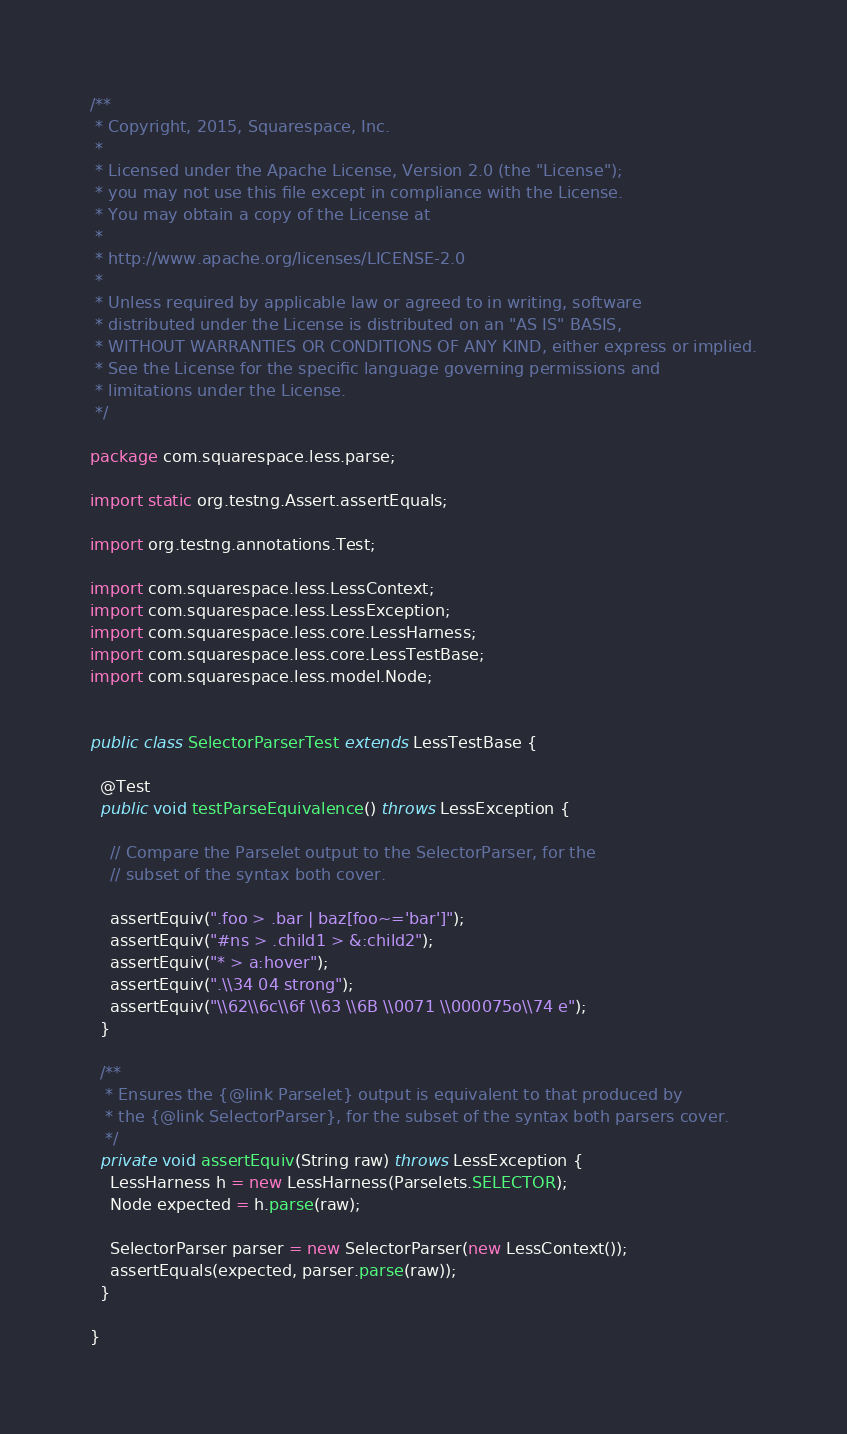Convert code to text. <code><loc_0><loc_0><loc_500><loc_500><_Java_>/**
 * Copyright, 2015, Squarespace, Inc.
 *
 * Licensed under the Apache License, Version 2.0 (the "License");
 * you may not use this file except in compliance with the License.
 * You may obtain a copy of the License at
 *
 * http://www.apache.org/licenses/LICENSE-2.0
 *
 * Unless required by applicable law or agreed to in writing, software
 * distributed under the License is distributed on an "AS IS" BASIS,
 * WITHOUT WARRANTIES OR CONDITIONS OF ANY KIND, either express or implied.
 * See the License for the specific language governing permissions and
 * limitations under the License.
 */

package com.squarespace.less.parse;

import static org.testng.Assert.assertEquals;

import org.testng.annotations.Test;

import com.squarespace.less.LessContext;
import com.squarespace.less.LessException;
import com.squarespace.less.core.LessHarness;
import com.squarespace.less.core.LessTestBase;
import com.squarespace.less.model.Node;


public class SelectorParserTest extends LessTestBase {

  @Test
  public void testParseEquivalence() throws LessException {

    // Compare the Parselet output to the SelectorParser, for the
    // subset of the syntax both cover.

    assertEquiv(".foo > .bar | baz[foo~='bar']");
    assertEquiv("#ns > .child1 > &:child2");
    assertEquiv("* > a:hover");
    assertEquiv(".\\34 04 strong");
    assertEquiv("\\62\\6c\\6f \\63 \\6B \\0071 \\000075o\\74 e");
  }

  /**
   * Ensures the {@link Parselet} output is equivalent to that produced by
   * the {@link SelectorParser}, for the subset of the syntax both parsers cover.
   */
  private void assertEquiv(String raw) throws LessException {
    LessHarness h = new LessHarness(Parselets.SELECTOR);
    Node expected = h.parse(raw);

    SelectorParser parser = new SelectorParser(new LessContext());
    assertEquals(expected, parser.parse(raw));
  }

}
</code> 